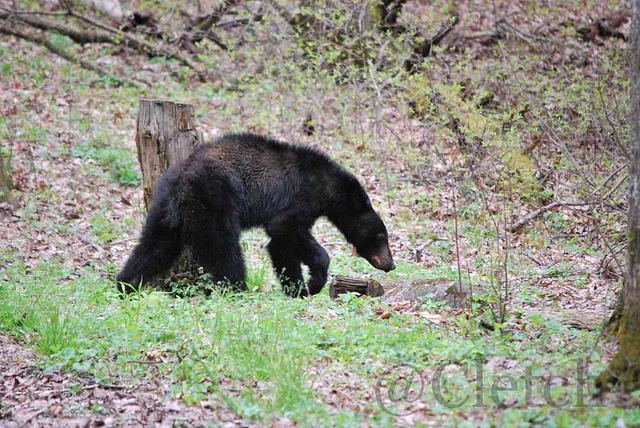What kind of bear is this?
Write a very short answer. Black. Where is the bear?
Keep it brief. Woods. Where is the photo taken?
Write a very short answer. Woods. What color is the animal?
Short answer required. Black. What surface is the bear touching?
Keep it brief. Grass. 